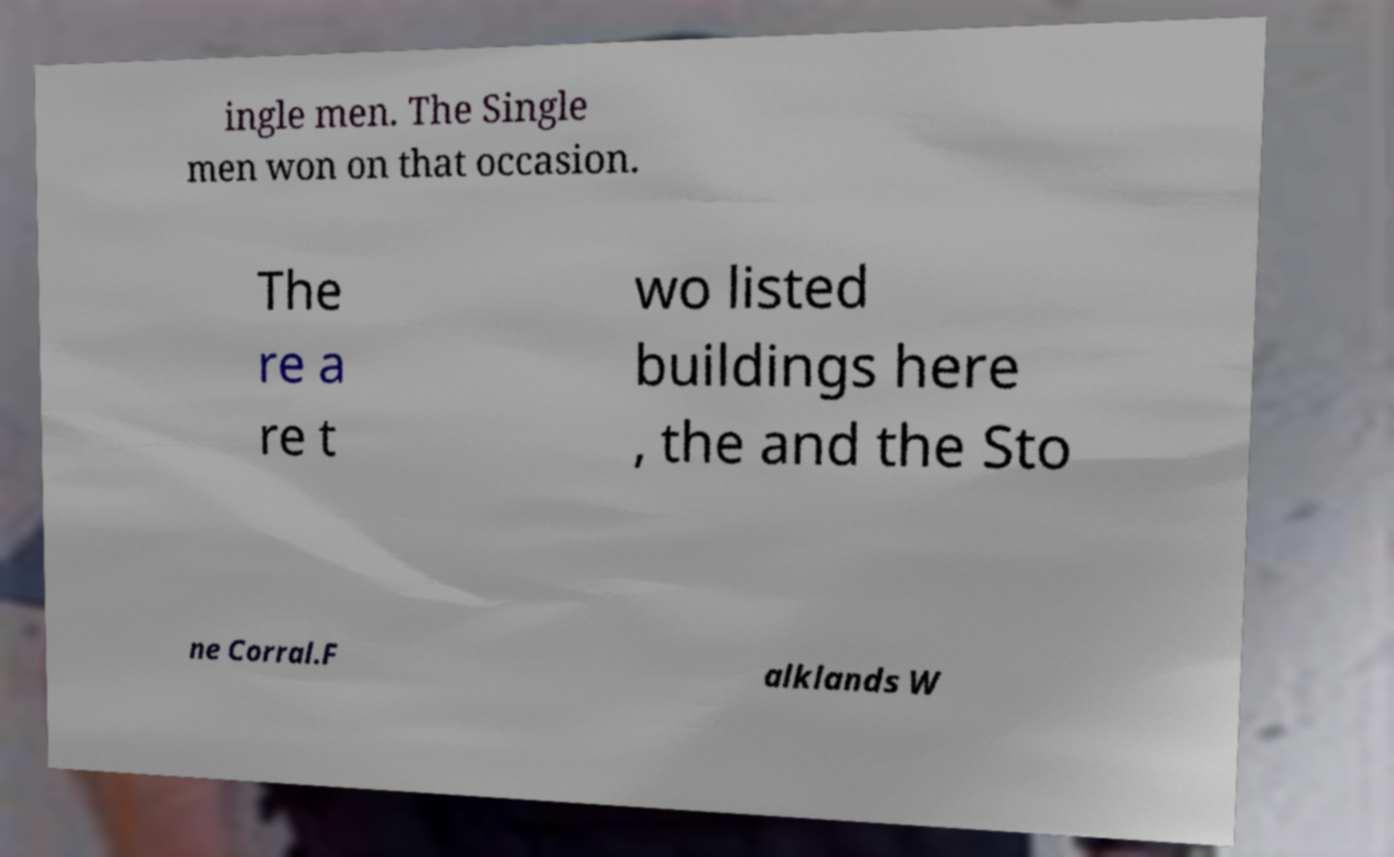Could you extract and type out the text from this image? ingle men. The Single men won on that occasion. The re a re t wo listed buildings here , the and the Sto ne Corral.F alklands W 